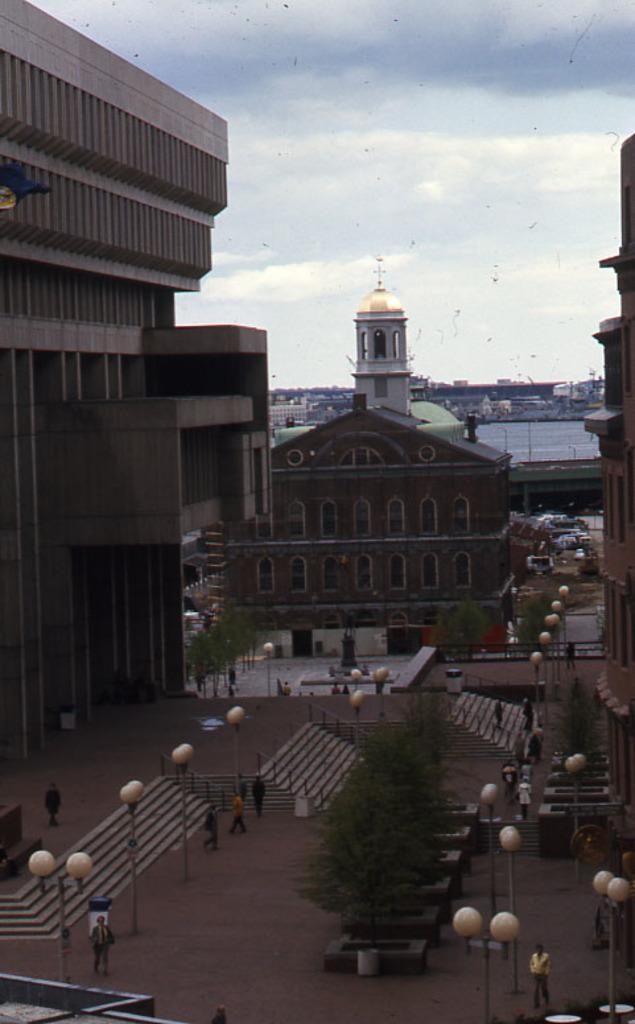What can be seen in the foreground of the image? In the foreground of the image, there are steps, street lights, trees, and persons. What type of structures are visible in the middle of the image? There are buildings in the middle of the image. What is visible at the top of the image? The sky is visible at the top of the image. Can you spot any squirrels playing in the wilderness in the image? There are no squirrels or wilderness present in the image. What time of day is it during recess in the image? The image does not depict a specific time of day or a recess; it shows a scene with steps, street lights, trees, persons, buildings, and the sky. 